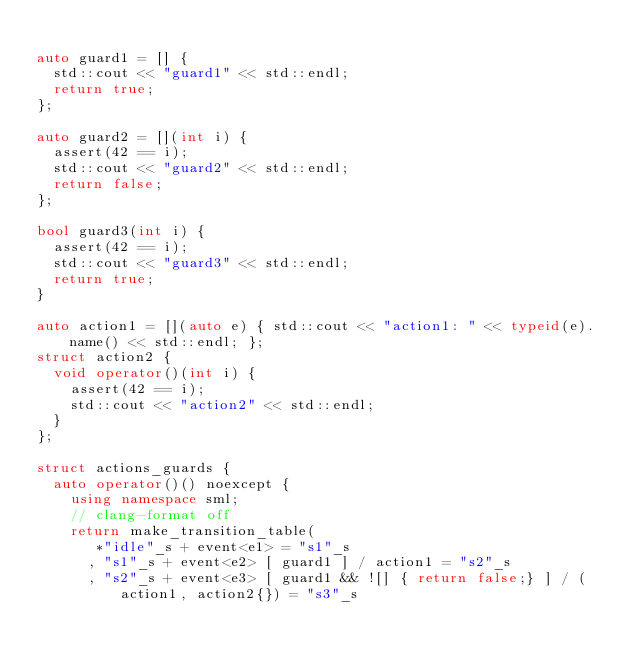Convert code to text. <code><loc_0><loc_0><loc_500><loc_500><_C++_>
auto guard1 = [] {
  std::cout << "guard1" << std::endl;
  return true;
};

auto guard2 = [](int i) {
  assert(42 == i);
  std::cout << "guard2" << std::endl;
  return false;
};

bool guard3(int i) {
  assert(42 == i);
  std::cout << "guard3" << std::endl;
  return true;
}

auto action1 = [](auto e) { std::cout << "action1: " << typeid(e).name() << std::endl; };
struct action2 {
  void operator()(int i) {
    assert(42 == i);
    std::cout << "action2" << std::endl;
  }
};

struct actions_guards {
  auto operator()() noexcept {
    using namespace sml;
    // clang-format off
    return make_transition_table(
       *"idle"_s + event<e1> = "s1"_s
      , "s1"_s + event<e2> [ guard1 ] / action1 = "s2"_s
      , "s2"_s + event<e3> [ guard1 && ![] { return false;} ] / (action1, action2{}) = "s3"_s</code> 